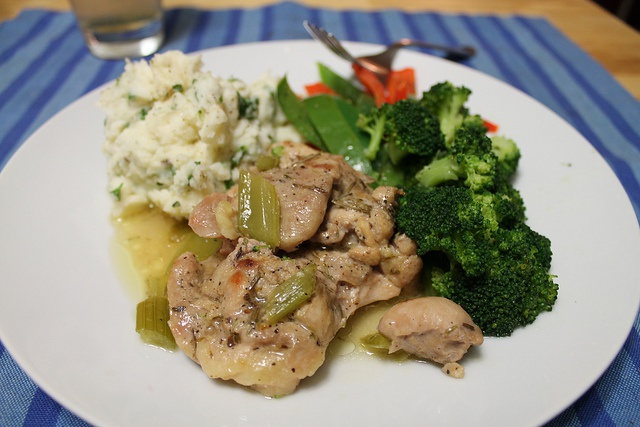Describe the objects in this image and their specific colors. I can see dining table in lightgray, tan, gray, black, and olive tones, broccoli in olive, black, and darkgreen tones, cup in olive, gray, and darkgray tones, fork in olive, gray, maroon, and darkgray tones, and carrot in olive, brown, red, and maroon tones in this image. 